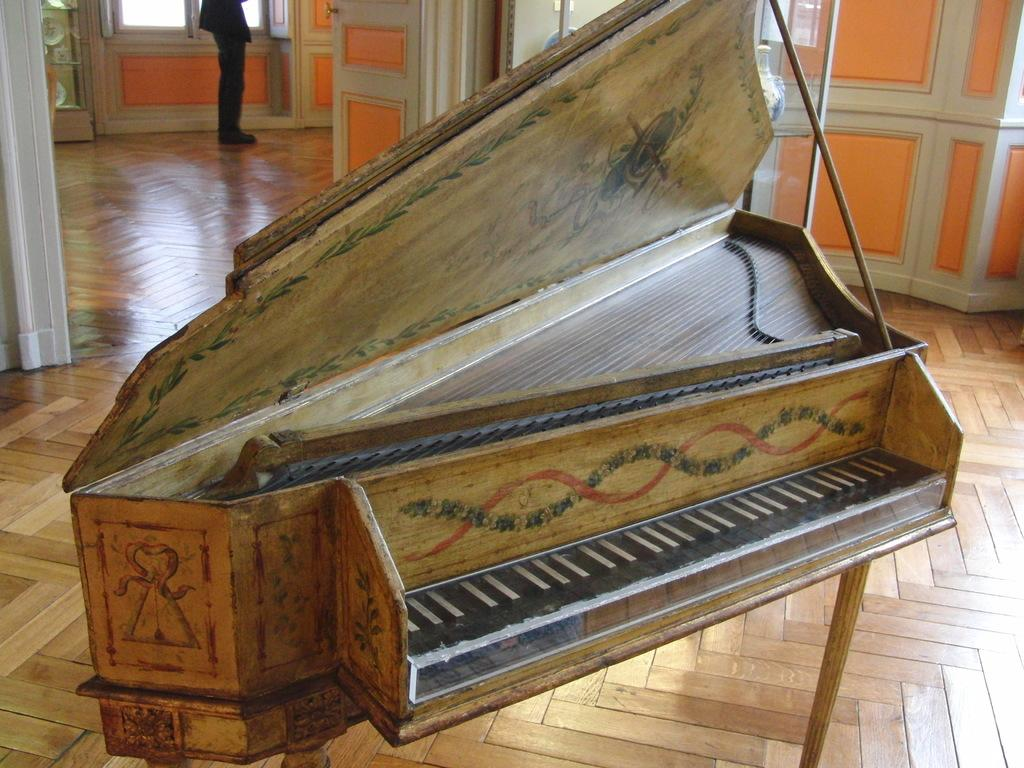What type of musical instrument is in the image? There is a wooden piano in the image. Who is present in the image? There is a person standing in the image. What is the person wearing? The person is wearing clothes and shoes. What type of surface is visible in the image? There is a wooden surface in the image. What architectural feature can be seen in the image? There is a door in the image. Can you tell me how many credits the person is reading in the image? There is no mention of credits or reading in the image; it features a wooden piano and a person standing near it. What type of drum is being played in the image? There is no drum present in the image; it features a wooden piano and a person standing near it. 